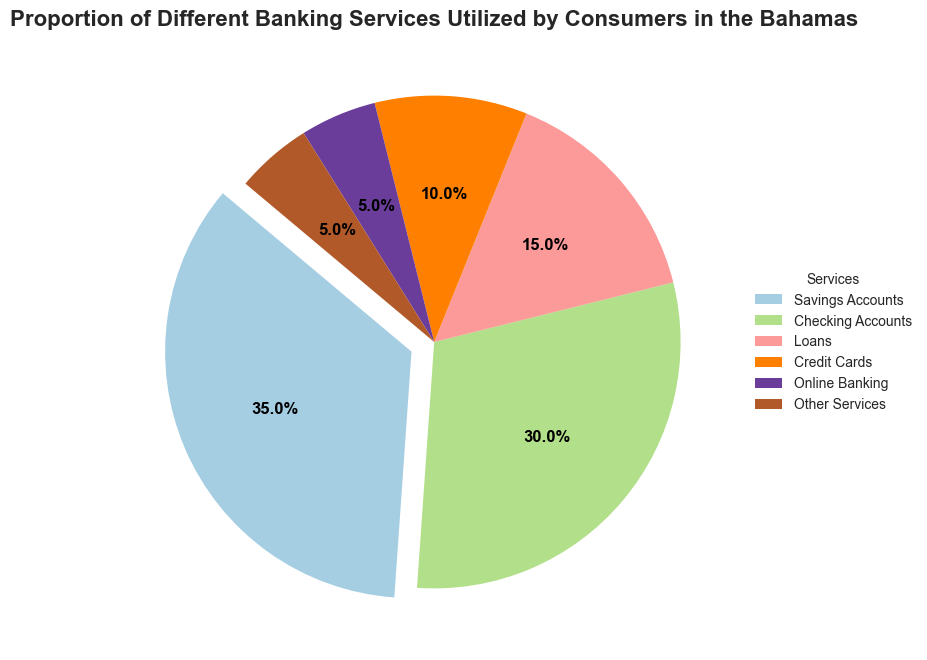Which banking service is used the most by consumers in the Bahamas? By looking at the pie chart, we can see that 'Savings Accounts' has the largest proportion in the pie, meaning it is the most used banking service.
Answer: Savings Accounts Which two banking services have the smallest proportion of use by consumers in the Bahamas? According to the pie chart, 'Online Banking' and 'Other Services' both have the smallest slices, each representing 5%.
Answer: Online Banking and Other Services What is the combined proportion of 'Checking Accounts' and 'Loans'? The chart shows that the proportion for 'Checking Accounts' is 30% and for 'Loans' is 15%. Adding these proportions together, 30% + 15% = 45%.
Answer: 45% How much more popular are 'Savings Accounts' compared to 'Credit Cards'? The pie chart indicates that 'Savings Accounts' have a proportion of 35%, and 'Credit Cards' have 10%. Subtracting the proportion of 'Credit Cards' from 'Savings Accounts', 35% - 10% = 25%.
Answer: 25% Which service has a slightly larger proportion: 'Loans' or 'Credit Cards'? The pie chart shows that 'Loans' have a proportion of 15%, which is larger than 'Credit Cards' with 10%.
Answer: Loans What is the total proportion of 'Savings Accounts', 'Checking Accounts', and 'Credit Cards'? From the pie chart, the proportions are 35% for 'Savings Accounts', 30% for 'Checking Accounts', and 10% for 'Credit Cards'. Summing them up, 35% + 30% + 10% = 75%.
Answer: 75% If we were to combine 'Online Banking' and 'Other Services' into a single category, what would be their new combined proportion, and how would it compare to 'Loans'? 'Online Banking' and 'Other Services' both have proportions of 5%. Their combined proportion is 5% + 5% = 10%, which equals the proportion for 'Loans'.
Answer: 10%, equal to Loans Between 'Checking Accounts' and 'Savings Accounts', which one is more popular, and by how much? The chart indicates that 'Checking Accounts' have a 30% proportion, while 'Savings Accounts' have a 35% proportion. The difference is 35% - 30% = 5%. Therefore, 'Savings Accounts' are more popular by 5%.
Answer: Savings Accounts, by 5% 